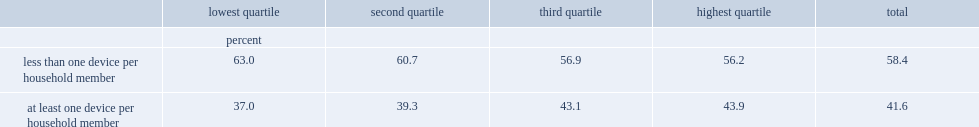Among households who had internet access at home,what was the percentage of those who had less than one internet-enabled device per household member. 58.4. Among households in the lowest income quartile,what was the percentage of those who had less than one internet-enabled device for each household member? 63.0. Among households in the highest income quartile,what was the percentage of those who had less than one device per household member? 56.2. Who were less likely to have less than one device per household member,households in the third quartile or those in the lowest quartile? Third quartile. 